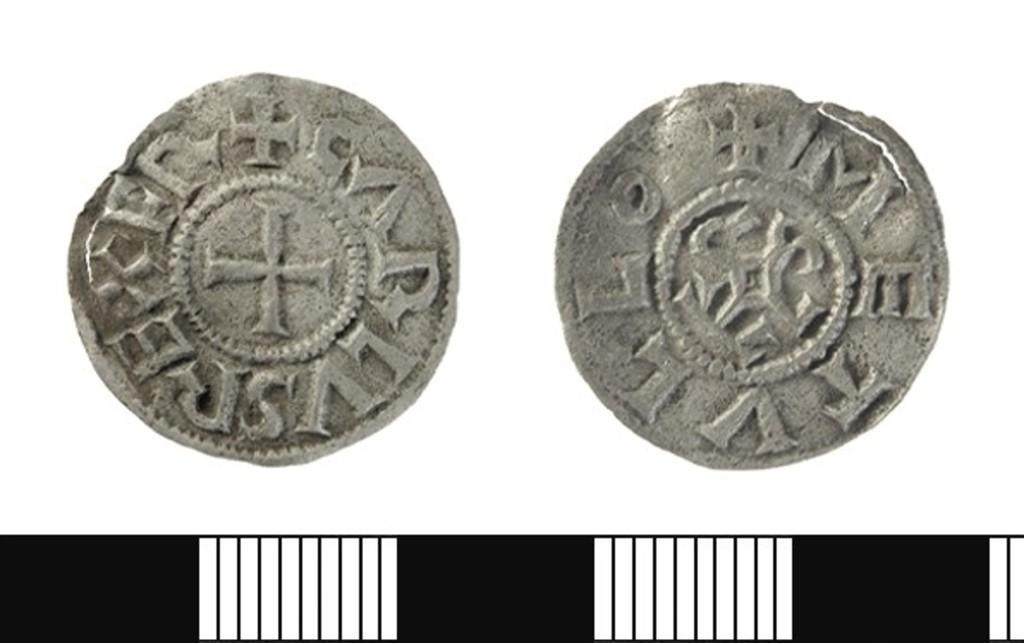How would you summarize this image in a sentence or two? This is an edited image. I can see two coins and there is a white background. 